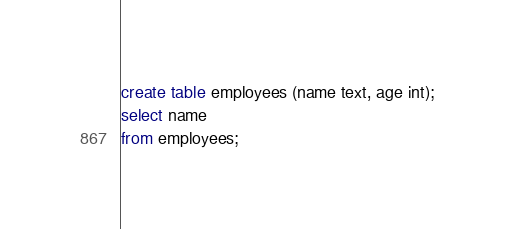<code> <loc_0><loc_0><loc_500><loc_500><_SQL_>create table employees (name text, age int);
select name
from employees;
</code> 